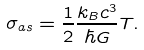Convert formula to latex. <formula><loc_0><loc_0><loc_500><loc_500>\sigma _ { a s } = \frac { 1 } { 2 } \frac { k _ { B } c ^ { 3 } } { \hbar { G } } T .</formula> 